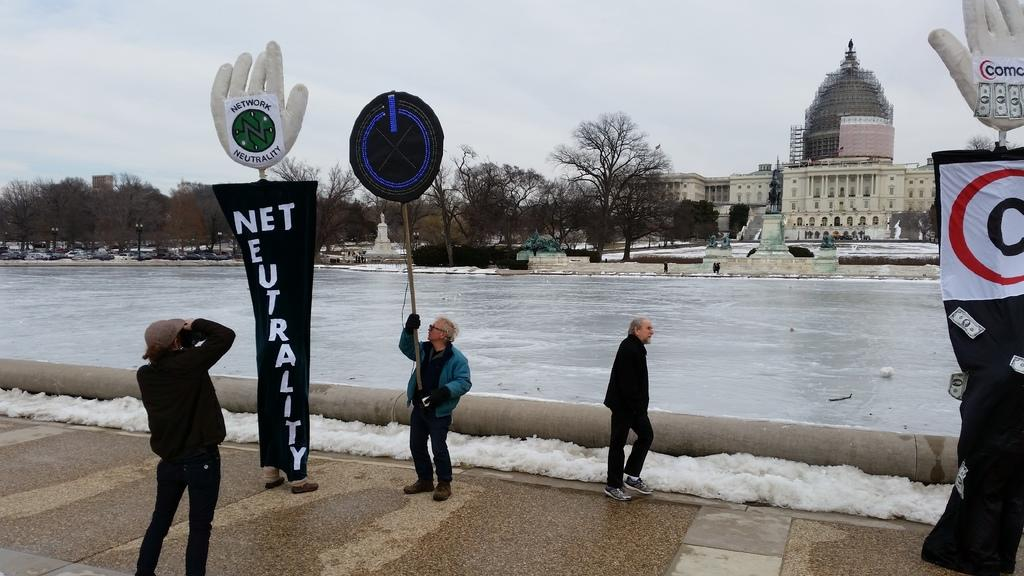<image>
Share a concise interpretation of the image provided. A few people outsides with sign about net neutrality. 